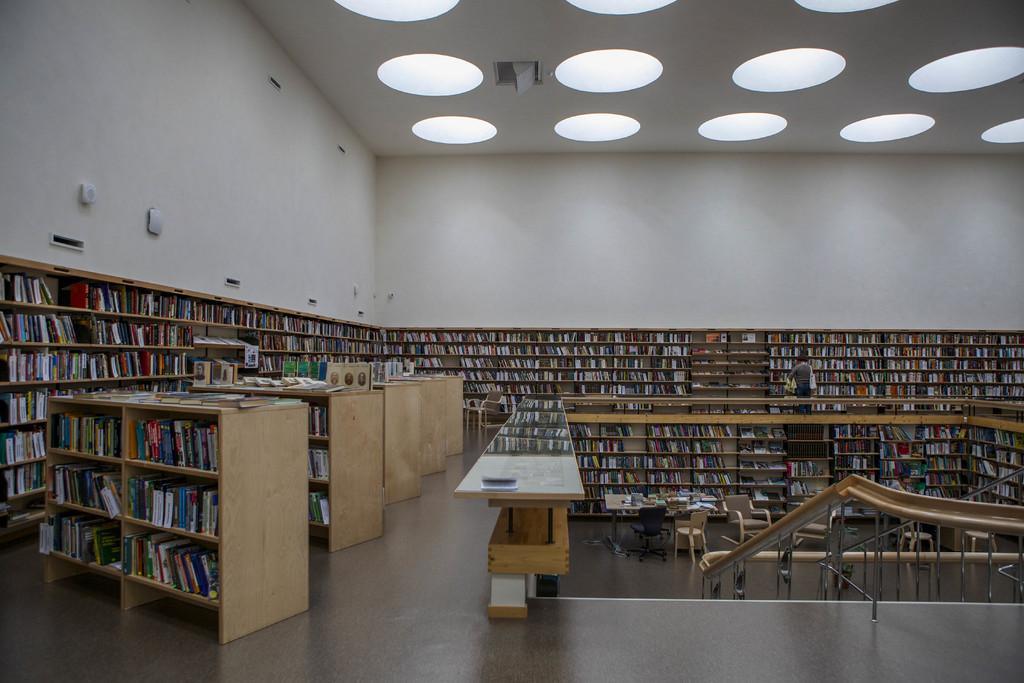In one or two sentences, can you explain what this image depicts? In this image I can see racks, tables, chairs, railing, walls, lights and objects. In-front of that rack I can see a person. Above the table there are objects. In that racks there are books.   